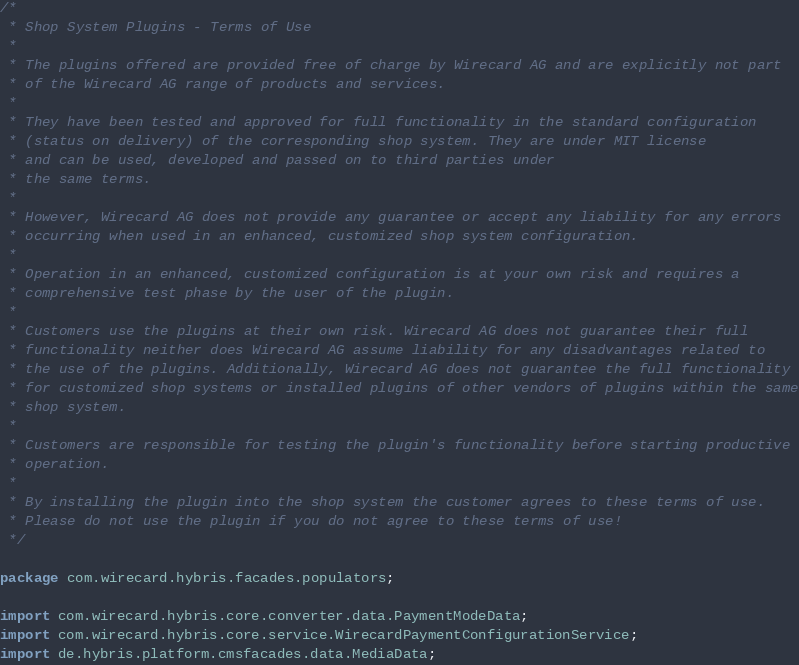Convert code to text. <code><loc_0><loc_0><loc_500><loc_500><_Java_>/*
 * Shop System Plugins - Terms of Use
 *
 * The plugins offered are provided free of charge by Wirecard AG and are explicitly not part
 * of the Wirecard AG range of products and services.
 *
 * They have been tested and approved for full functionality in the standard configuration
 * (status on delivery) of the corresponding shop system. They are under MIT license
 * and can be used, developed and passed on to third parties under
 * the same terms.
 *
 * However, Wirecard AG does not provide any guarantee or accept any liability for any errors
 * occurring when used in an enhanced, customized shop system configuration.
 *
 * Operation in an enhanced, customized configuration is at your own risk and requires a
 * comprehensive test phase by the user of the plugin.
 *
 * Customers use the plugins at their own risk. Wirecard AG does not guarantee their full
 * functionality neither does Wirecard AG assume liability for any disadvantages related to
 * the use of the plugins. Additionally, Wirecard AG does not guarantee the full functionality
 * for customized shop systems or installed plugins of other vendors of plugins within the same
 * shop system.
 *
 * Customers are responsible for testing the plugin's functionality before starting productive
 * operation.
 *
 * By installing the plugin into the shop system the customer agrees to these terms of use.
 * Please do not use the plugin if you do not agree to these terms of use!
 */

package com.wirecard.hybris.facades.populators;

import com.wirecard.hybris.core.converter.data.PaymentModeData;
import com.wirecard.hybris.core.service.WirecardPaymentConfigurationService;
import de.hybris.platform.cmsfacades.data.MediaData;</code> 